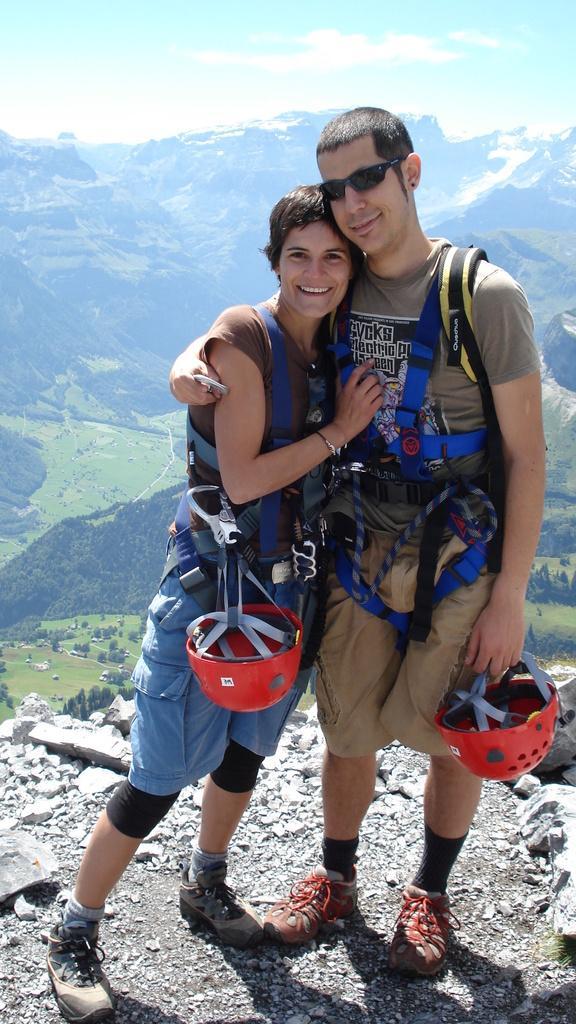In one or two sentences, can you explain what this image depicts? These two persons are standing side by side and giving stills. These people are smiling, wore goggle and holding a helmets. Far there are mountains. At the bottom there are trees and grass. 